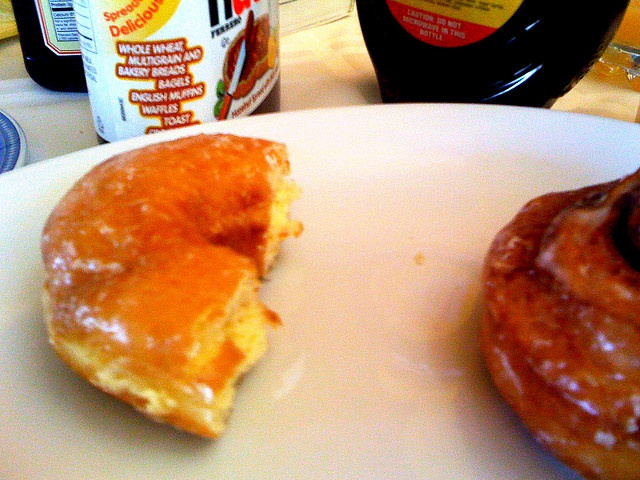Describe the objects in this image and their specific colors. I can see dining table in tan, lightgray, red, black, and maroon tones, donut in olive, red, and orange tones, donut in olive, maroon, brown, and black tones, bottle in olive, lightblue, brown, and maroon tones, and bottle in olive, black, and maroon tones in this image. 